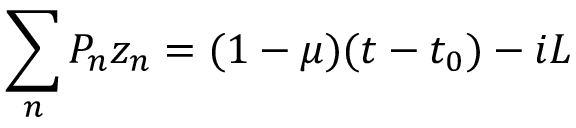Convert formula to latex. <formula><loc_0><loc_0><loc_500><loc_500>\sum _ { n } P _ { n } z _ { n } = ( 1 - \mu ) ( t - t _ { 0 } ) - i L</formula> 